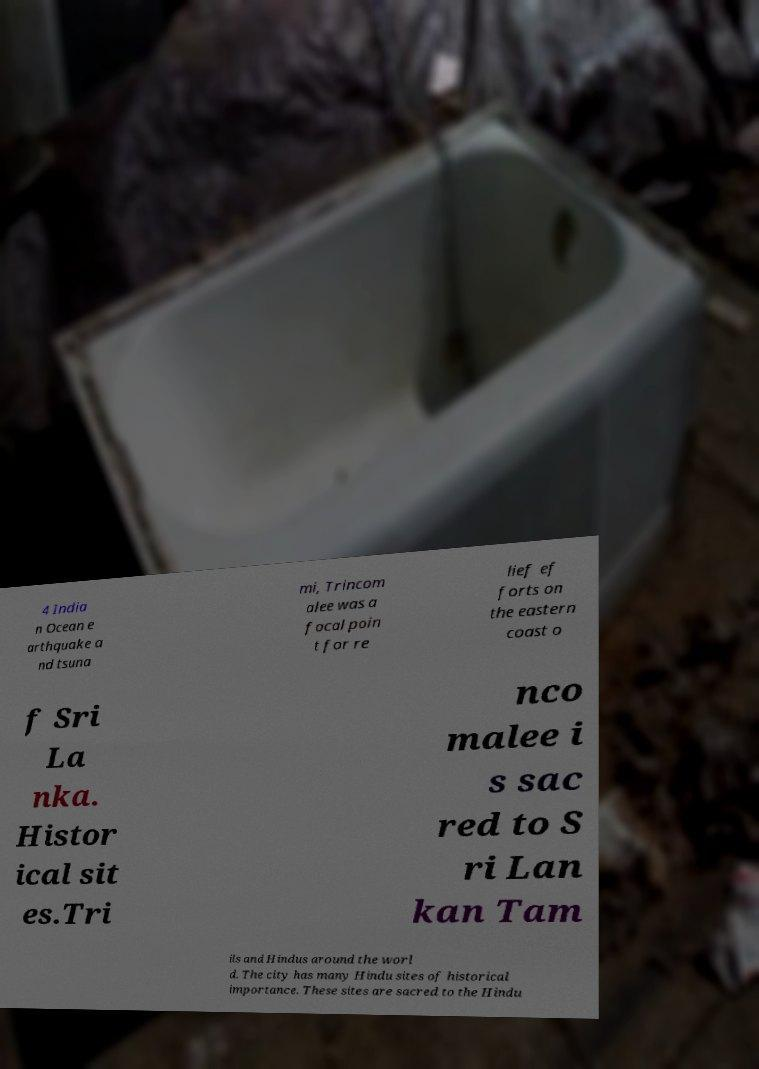Can you read and provide the text displayed in the image?This photo seems to have some interesting text. Can you extract and type it out for me? 4 India n Ocean e arthquake a nd tsuna mi, Trincom alee was a focal poin t for re lief ef forts on the eastern coast o f Sri La nka. Histor ical sit es.Tri nco malee i s sac red to S ri Lan kan Tam ils and Hindus around the worl d. The city has many Hindu sites of historical importance. These sites are sacred to the Hindu 